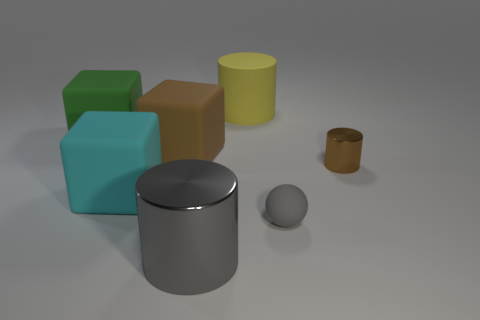Subtract all large cylinders. How many cylinders are left? 1 Add 3 balls. How many objects exist? 10 Subtract all gray cylinders. How many cylinders are left? 2 Subtract 2 cylinders. How many cylinders are left? 1 Subtract all blue cubes. Subtract all green balls. How many cubes are left? 3 Subtract all purple cylinders. How many brown blocks are left? 1 Subtract all brown matte objects. Subtract all green matte blocks. How many objects are left? 5 Add 6 big yellow rubber things. How many big yellow rubber things are left? 7 Add 3 cyan balls. How many cyan balls exist? 3 Subtract 1 yellow cylinders. How many objects are left? 6 